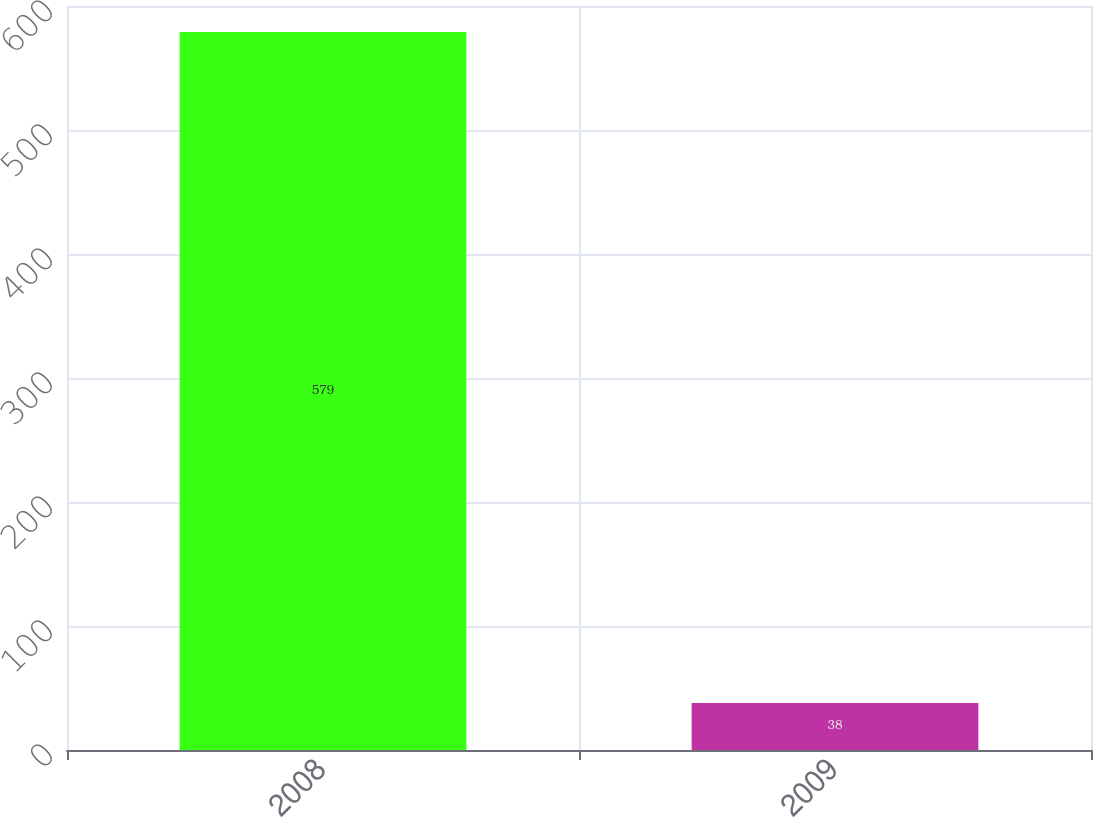Convert chart to OTSL. <chart><loc_0><loc_0><loc_500><loc_500><bar_chart><fcel>2008<fcel>2009<nl><fcel>579<fcel>38<nl></chart> 